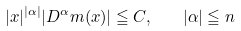<formula> <loc_0><loc_0><loc_500><loc_500>| x | ^ { | \alpha | } | D ^ { \alpha } m ( x ) | \leqq C , \quad | \alpha | \leqq n</formula> 